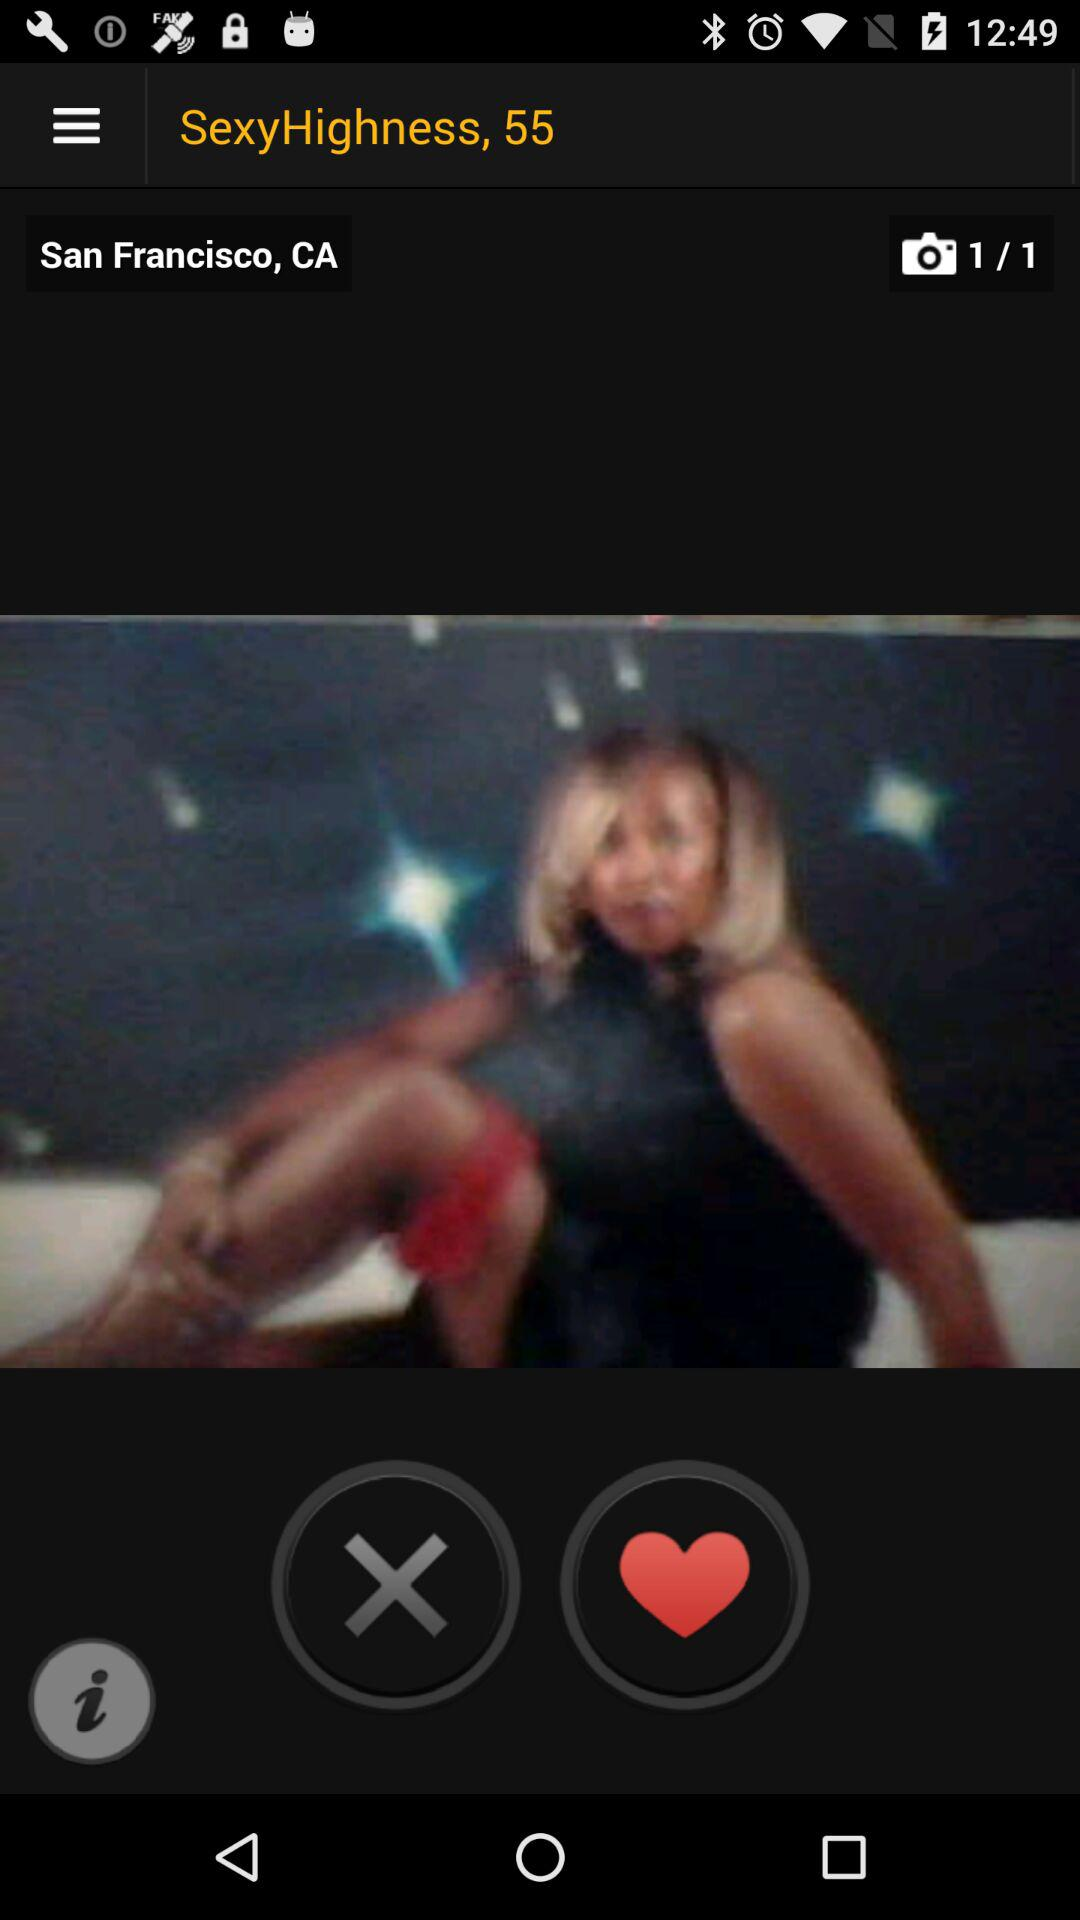What is the location? The location is San Francisco, CA. 